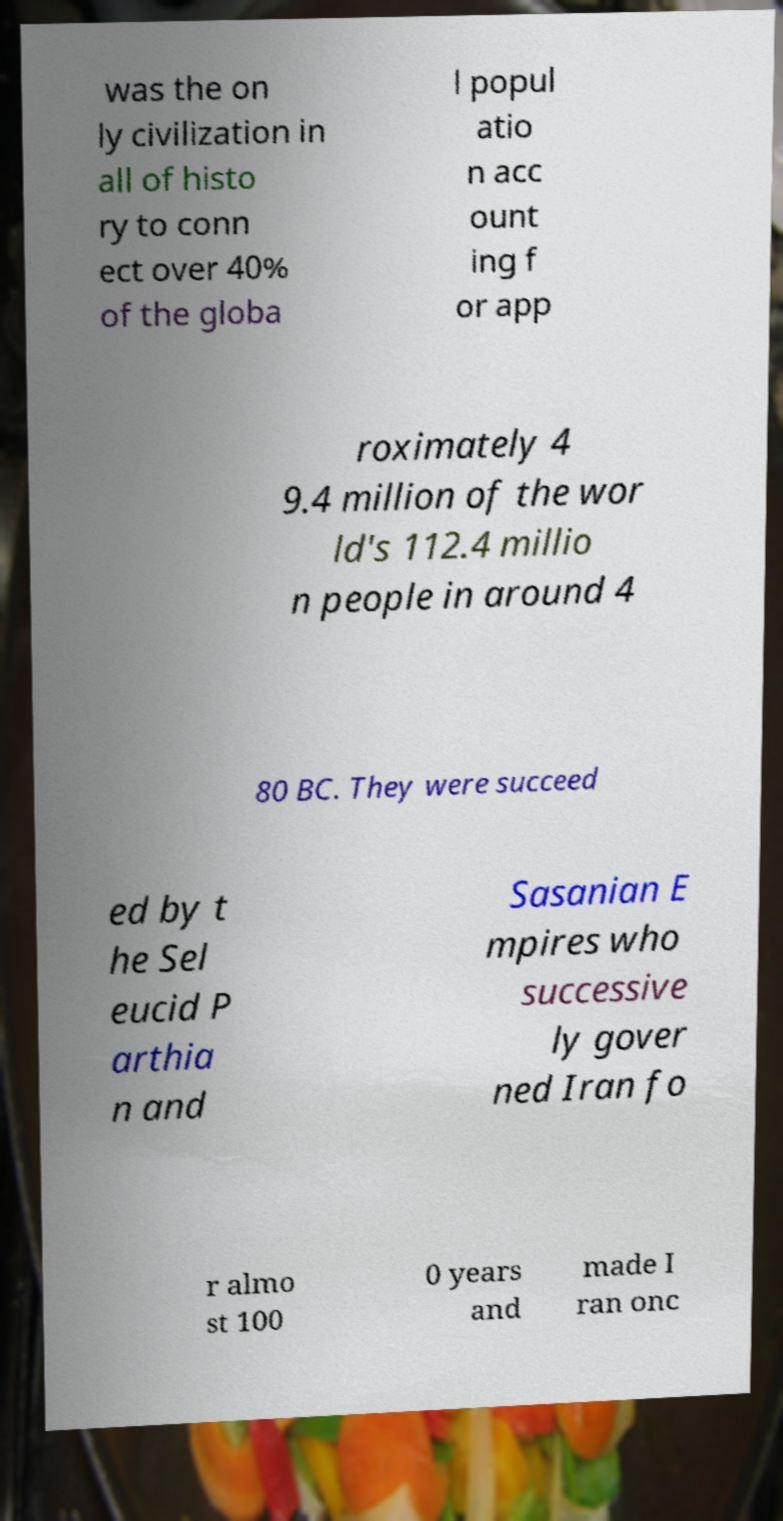For documentation purposes, I need the text within this image transcribed. Could you provide that? was the on ly civilization in all of histo ry to conn ect over 40% of the globa l popul atio n acc ount ing f or app roximately 4 9.4 million of the wor ld's 112.4 millio n people in around 4 80 BC. They were succeed ed by t he Sel eucid P arthia n and Sasanian E mpires who successive ly gover ned Iran fo r almo st 100 0 years and made I ran onc 